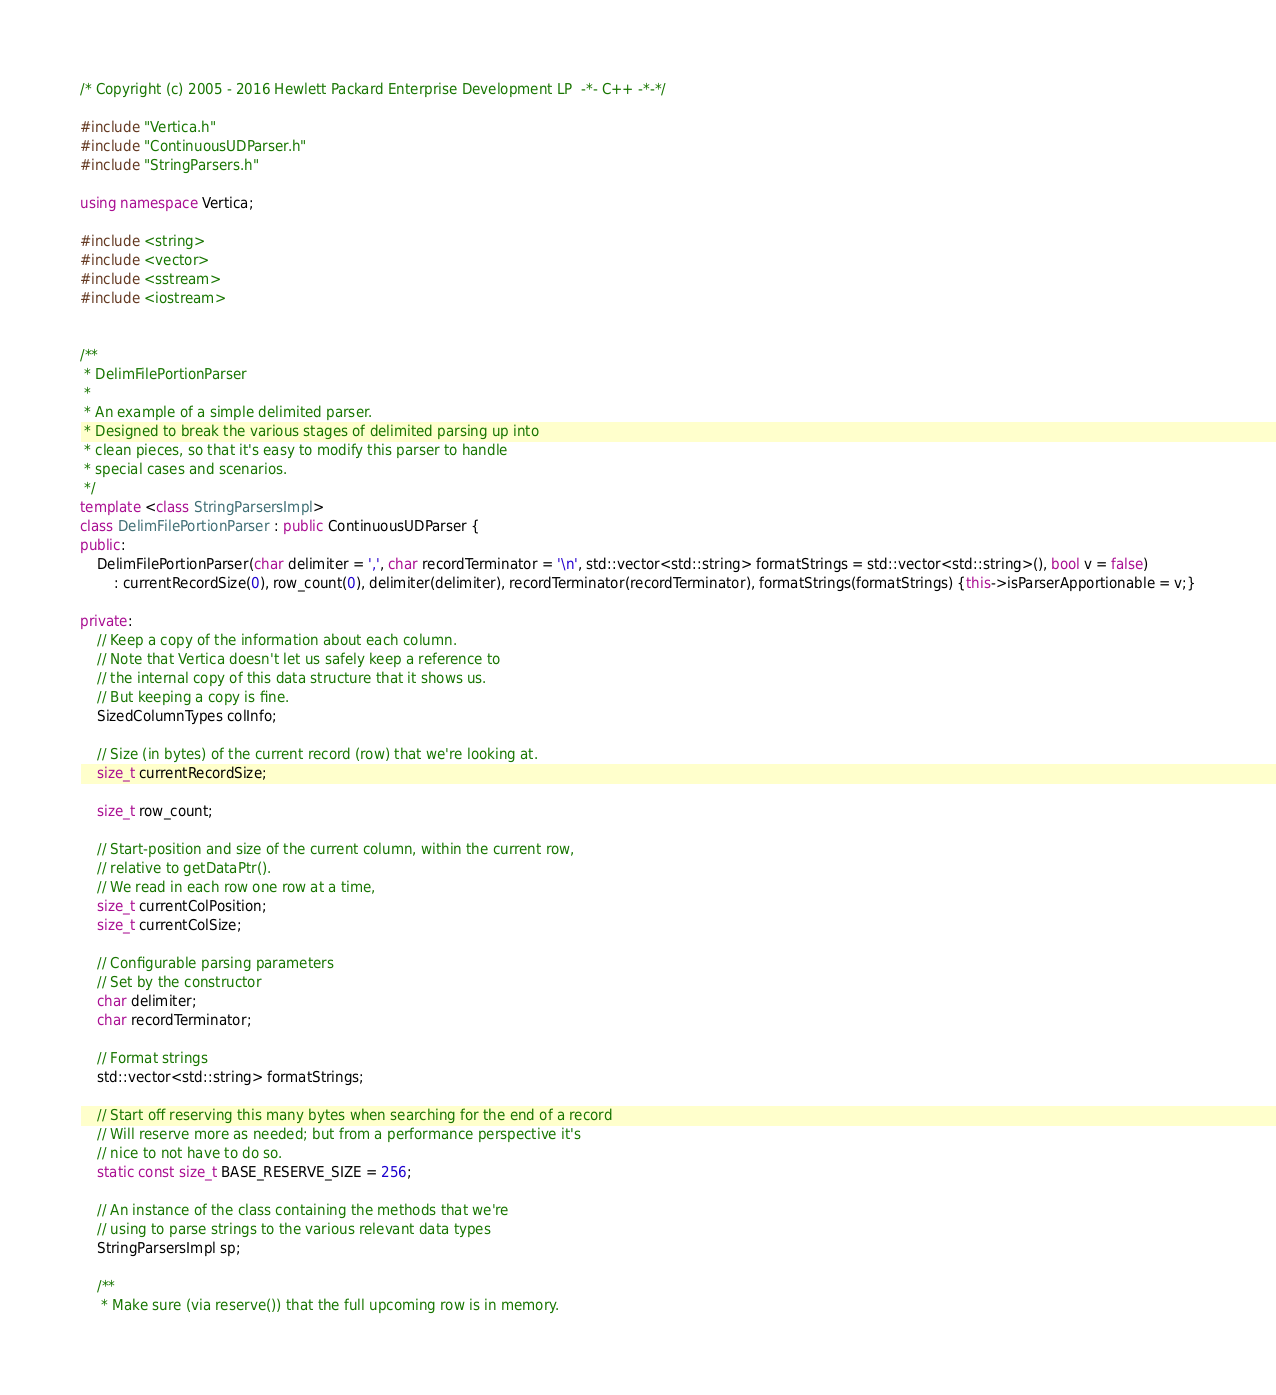<code> <loc_0><loc_0><loc_500><loc_500><_C++_>/* Copyright (c) 2005 - 2016 Hewlett Packard Enterprise Development LP  -*- C++ -*-*/

#include "Vertica.h"
#include "ContinuousUDParser.h"
#include "StringParsers.h"

using namespace Vertica;

#include <string>
#include <vector>
#include <sstream>
#include <iostream>


/**
 * DelimFilePortionParser
 *
 * An example of a simple delimited parser.
 * Designed to break the various stages of delimited parsing up into
 * clean pieces, so that it's easy to modify this parser to handle
 * special cases and scenarios.
 */
template <class StringParsersImpl>
class DelimFilePortionParser : public ContinuousUDParser {
public:
    DelimFilePortionParser(char delimiter = ',', char recordTerminator = '\n', std::vector<std::string> formatStrings = std::vector<std::string>(), bool v = false)
        : currentRecordSize(0), row_count(0), delimiter(delimiter), recordTerminator(recordTerminator), formatStrings(formatStrings) {this->isParserApportionable = v;}

private:
    // Keep a copy of the information about each column.
    // Note that Vertica doesn't let us safely keep a reference to
    // the internal copy of this data structure that it shows us.
    // But keeping a copy is fine.
    SizedColumnTypes colInfo;

    // Size (in bytes) of the current record (row) that we're looking at.
    size_t currentRecordSize;

    size_t row_count;

    // Start-position and size of the current column, within the current row,
    // relative to getDataPtr().
    // We read in each row one row at a time,
    size_t currentColPosition;
    size_t currentColSize;

    // Configurable parsing parameters
    // Set by the constructor
    char delimiter;
    char recordTerminator;

    // Format strings
    std::vector<std::string> formatStrings;

    // Start off reserving this many bytes when searching for the end of a record
    // Will reserve more as needed; but from a performance perspective it's
    // nice to not have to do so.
    static const size_t BASE_RESERVE_SIZE = 256;

    // An instance of the class containing the methods that we're
    // using to parse strings to the various relevant data types
    StringParsersImpl sp;

    /**
     * Make sure (via reserve()) that the full upcoming row is in memory.</code> 